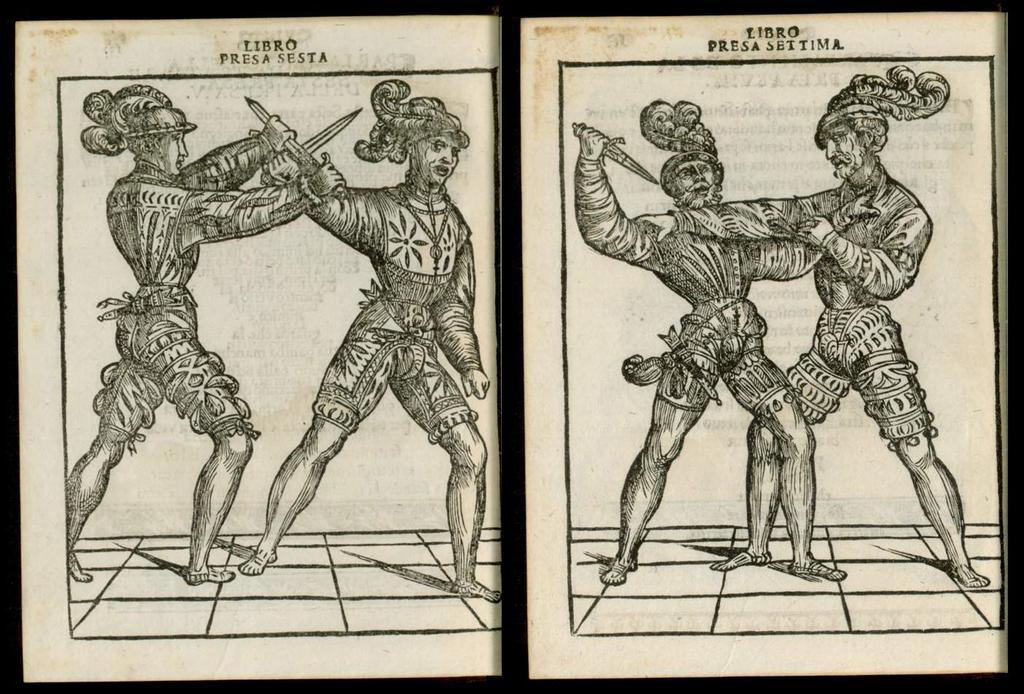Could you give a brief overview of what you see in this image? In the image its a photo frame and its a black and white cartoonistic image where in the left side of the photo there are two men who are fighting with a sword and on the right side there are two men fighting with hands and on floor it is a shadow which is seen and on the top of the photo it is written "Libro Presa Sesta". 